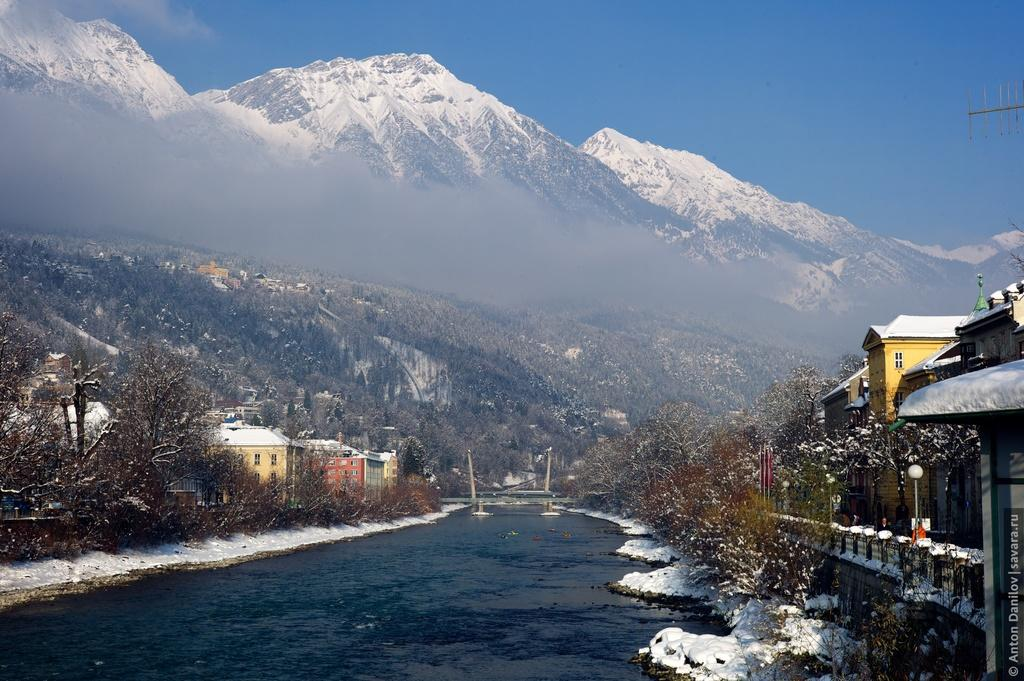What type of structures can be seen in the image? There are buildings in the image. What architectural features can be observed on the buildings? Windows are visible in the image. What natural elements are present in the image? There are trees, snow, water, and mountains in the image. What man-made structures are present in the image? There are light poles and a bridge in the image. What is the color of the sky in the image? The sky is blue in color. How many additions have been made to the bridge in the image? There is no mention of any additions being made to the bridge in the image. What type of destruction can be seen happening to the mountains in the image? There is no destruction visible in the image; the mountains appear intact. 